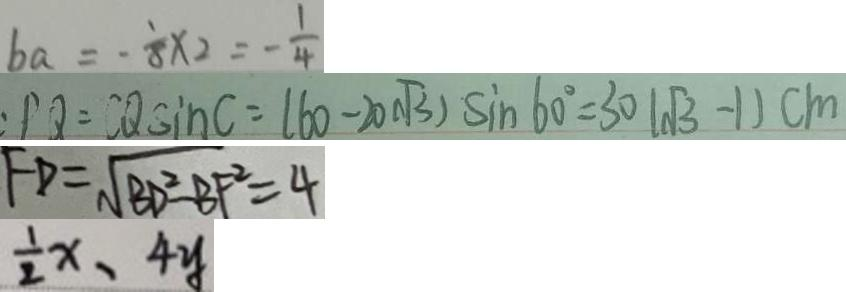<formula> <loc_0><loc_0><loc_500><loc_500>b a = - \frac { 1 } { 8 } \times 2 = - \frac { 1 } { 4 } 
 : P Q = C Q \sin C = ( 6 0 - 2 0 \sqrt { 3 } ) \sin 6 0 ^ { \circ } = 3 0 ( \sqrt { 3 } - 1 ) c m 
 F D = \sqrt { B D ^ { 2 } - B F ^ { 2 } } = 4 
 \frac { 1 } { 2 } x 、 4 y</formula> 